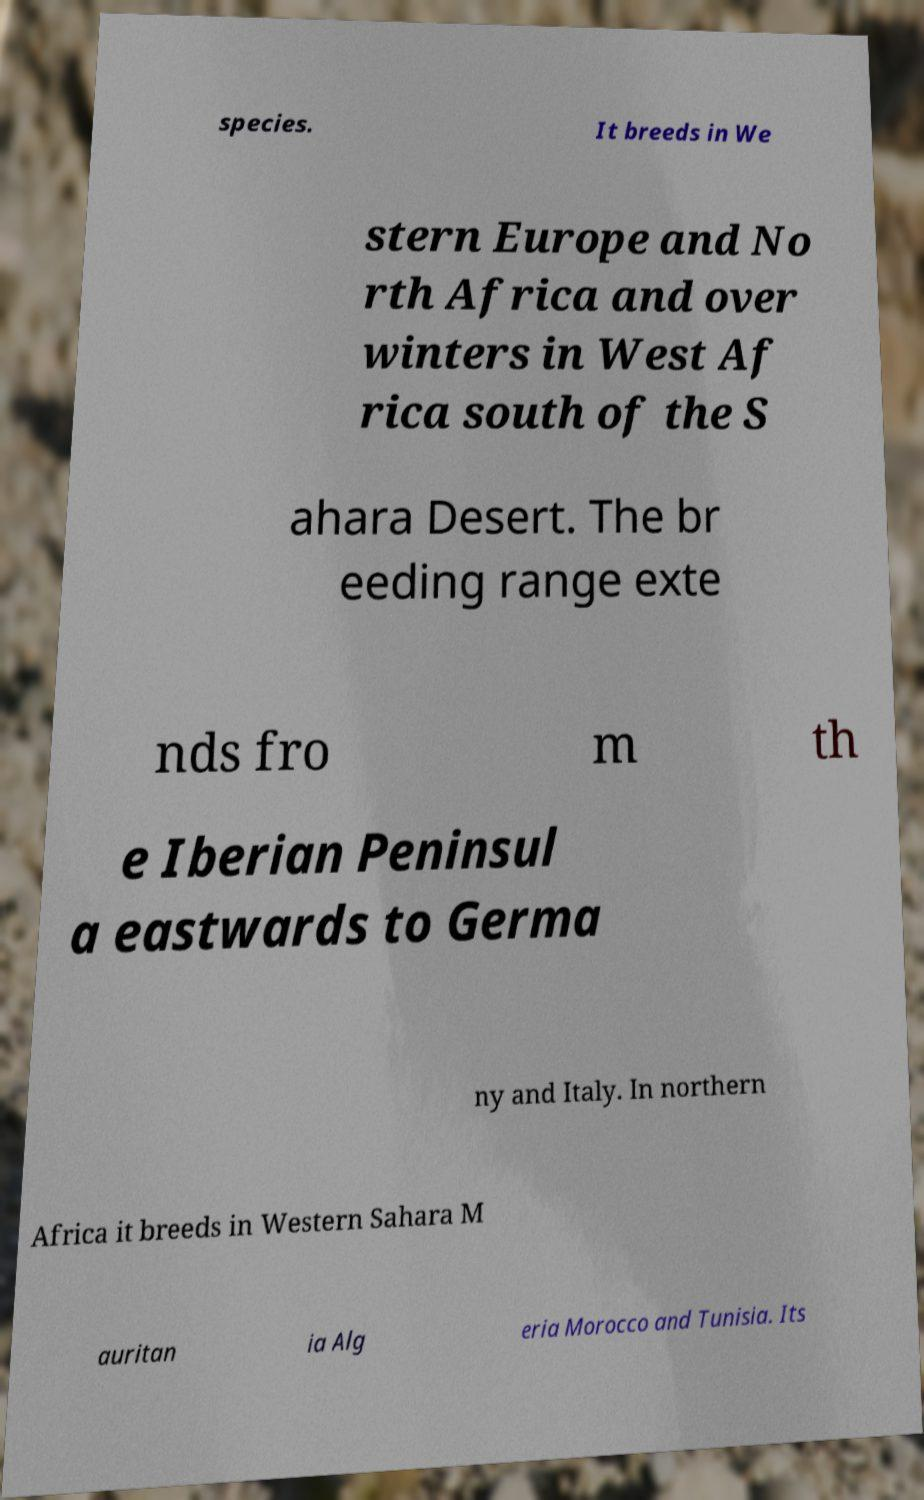Please identify and transcribe the text found in this image. species. It breeds in We stern Europe and No rth Africa and over winters in West Af rica south of the S ahara Desert. The br eeding range exte nds fro m th e Iberian Peninsul a eastwards to Germa ny and Italy. In northern Africa it breeds in Western Sahara M auritan ia Alg eria Morocco and Tunisia. Its 